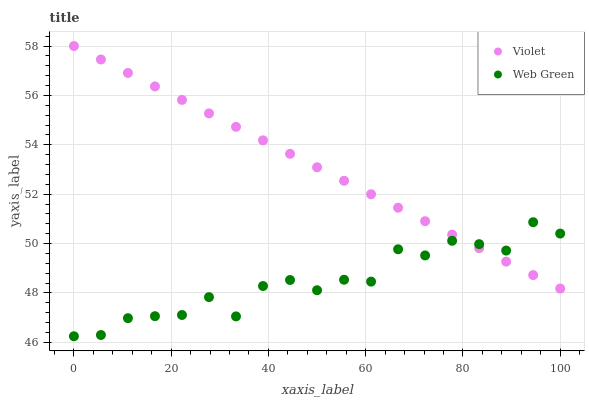Does Web Green have the minimum area under the curve?
Answer yes or no. Yes. Does Violet have the maximum area under the curve?
Answer yes or no. Yes. Does Violet have the minimum area under the curve?
Answer yes or no. No. Is Violet the smoothest?
Answer yes or no. Yes. Is Web Green the roughest?
Answer yes or no. Yes. Is Violet the roughest?
Answer yes or no. No. Does Web Green have the lowest value?
Answer yes or no. Yes. Does Violet have the lowest value?
Answer yes or no. No. Does Violet have the highest value?
Answer yes or no. Yes. Does Web Green intersect Violet?
Answer yes or no. Yes. Is Web Green less than Violet?
Answer yes or no. No. Is Web Green greater than Violet?
Answer yes or no. No. 